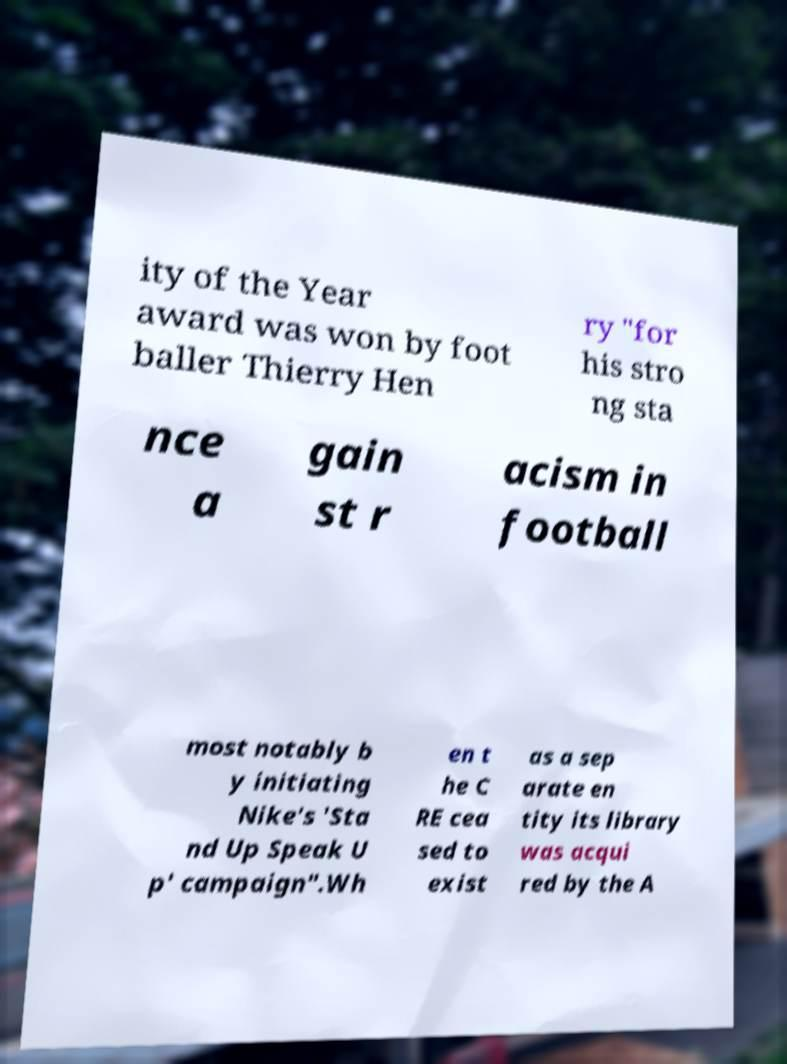What messages or text are displayed in this image? I need them in a readable, typed format. ity of the Year award was won by foot baller Thierry Hen ry "for his stro ng sta nce a gain st r acism in football most notably b y initiating Nike's 'Sta nd Up Speak U p' campaign".Wh en t he C RE cea sed to exist as a sep arate en tity its library was acqui red by the A 